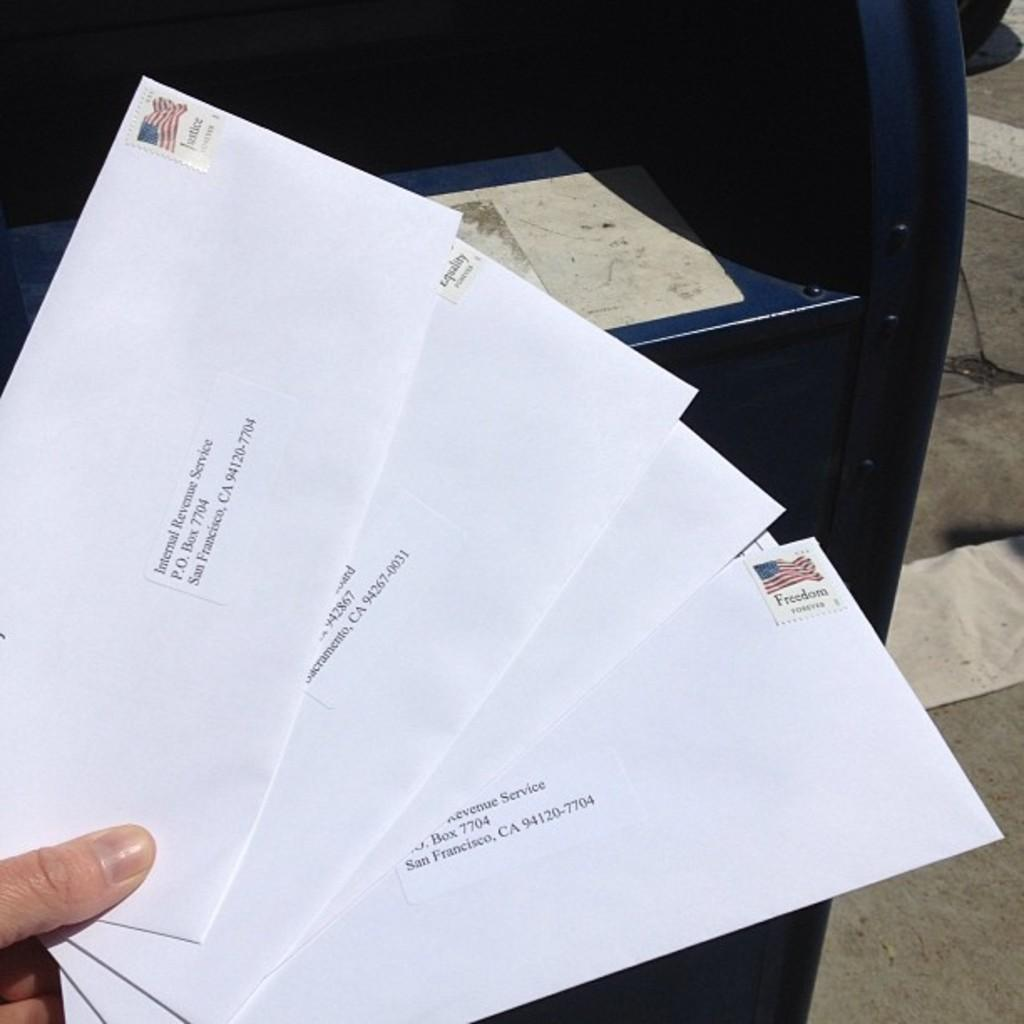<image>
Give a short and clear explanation of the subsequent image. A close of of someone holding several letters addresses to the IRS as they are about to be posted. 